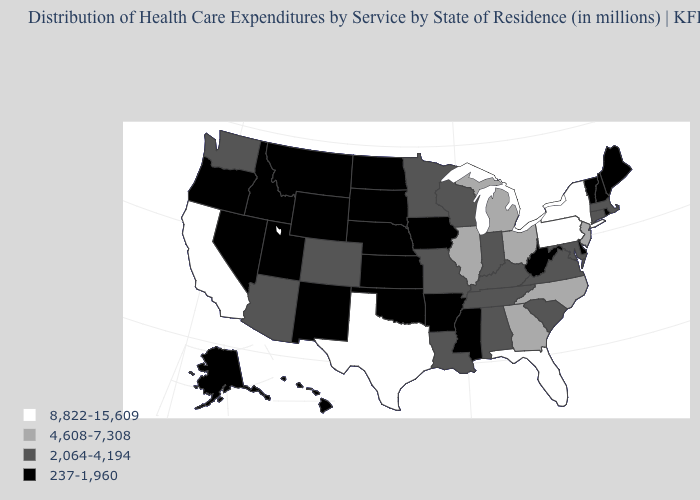Which states hav the highest value in the West?
Give a very brief answer. California. Name the states that have a value in the range 2,064-4,194?
Answer briefly. Alabama, Arizona, Colorado, Connecticut, Indiana, Kentucky, Louisiana, Maryland, Massachusetts, Minnesota, Missouri, South Carolina, Tennessee, Virginia, Washington, Wisconsin. How many symbols are there in the legend?
Concise answer only. 4. What is the value of Alabama?
Be succinct. 2,064-4,194. Name the states that have a value in the range 8,822-15,609?
Give a very brief answer. California, Florida, New York, Pennsylvania, Texas. Does Idaho have the same value as South Carolina?
Write a very short answer. No. Does Hawaii have the same value as Nevada?
Write a very short answer. Yes. Does North Carolina have the same value as Illinois?
Write a very short answer. Yes. Among the states that border Mississippi , does Alabama have the lowest value?
Answer briefly. No. Does Ohio have a lower value than Missouri?
Write a very short answer. No. Does the map have missing data?
Answer briefly. No. What is the lowest value in the USA?
Answer briefly. 237-1,960. What is the value of West Virginia?
Answer briefly. 237-1,960. What is the value of Mississippi?
Give a very brief answer. 237-1,960. Which states have the lowest value in the USA?
Write a very short answer. Alaska, Arkansas, Delaware, Hawaii, Idaho, Iowa, Kansas, Maine, Mississippi, Montana, Nebraska, Nevada, New Hampshire, New Mexico, North Dakota, Oklahoma, Oregon, Rhode Island, South Dakota, Utah, Vermont, West Virginia, Wyoming. 